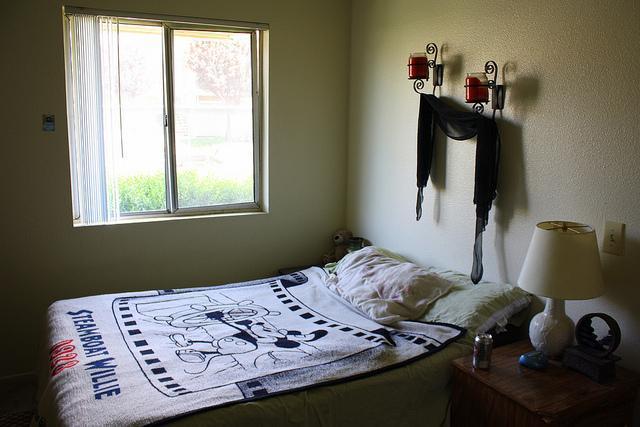How many bike are here?
Give a very brief answer. 0. 